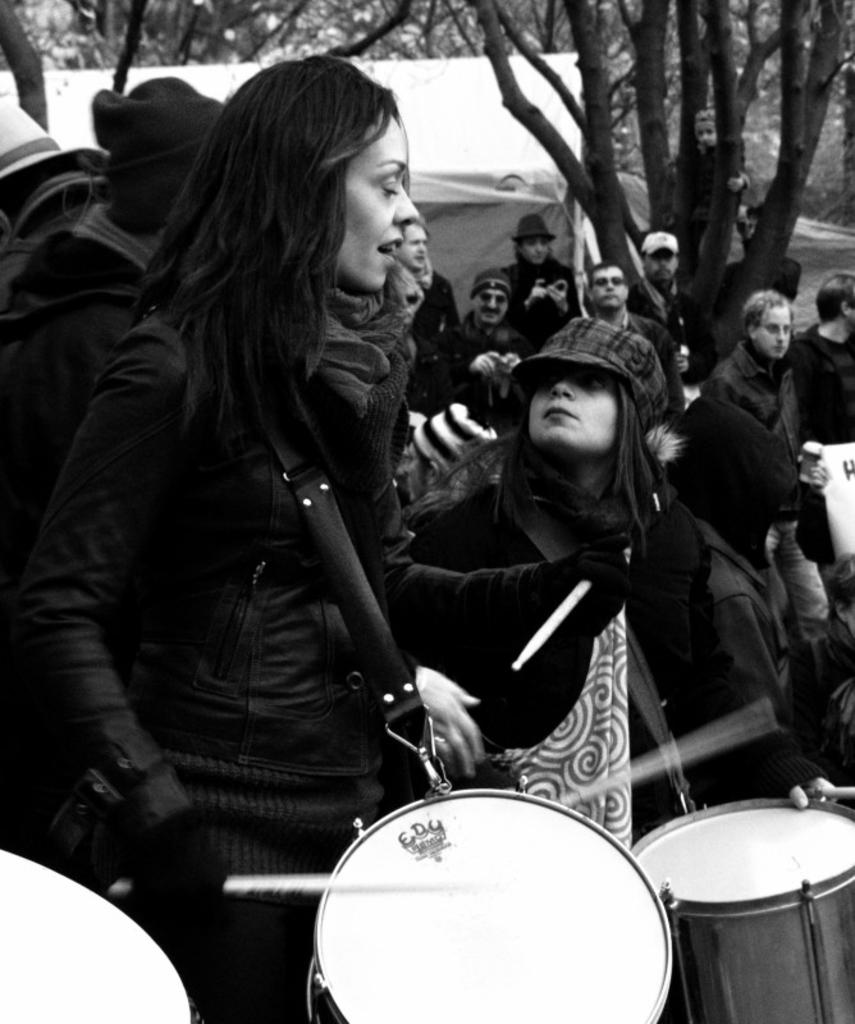What is the main subject of the image? The main subject of the image is a group of people. What are some of the people in the group doing? Some people in the group are holding drums. What can be seen in the background of the image? There is a tent and trees in the background of the image. Can you see any snails crawling on the bed in the image? There is no bed or snails present in the image. 